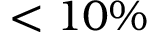Convert formula to latex. <formula><loc_0><loc_0><loc_500><loc_500>< 1 0 \%</formula> 